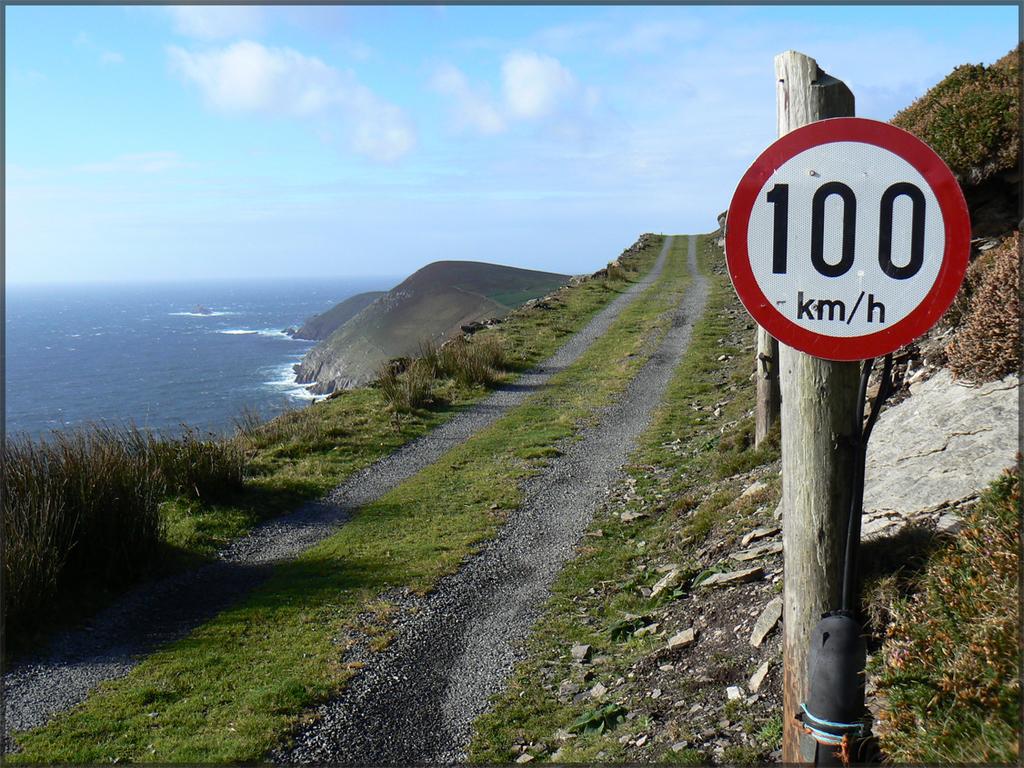What is the speed limit on this road?
Keep it short and to the point. 100 km/h. What type of distance do you measure speed?
Your answer should be compact. Km/h. 